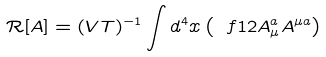Convert formula to latex. <formula><loc_0><loc_0><loc_500><loc_500>\mathcal { R } [ A ] = ( V T ) ^ { - 1 } \int d ^ { 4 } x \left ( \ f { 1 } { 2 } A _ { \mu } ^ { a } A ^ { \mu a } \right )</formula> 